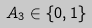<formula> <loc_0><loc_0><loc_500><loc_500>A _ { 3 } \in \{ 0 , 1 \}</formula> 